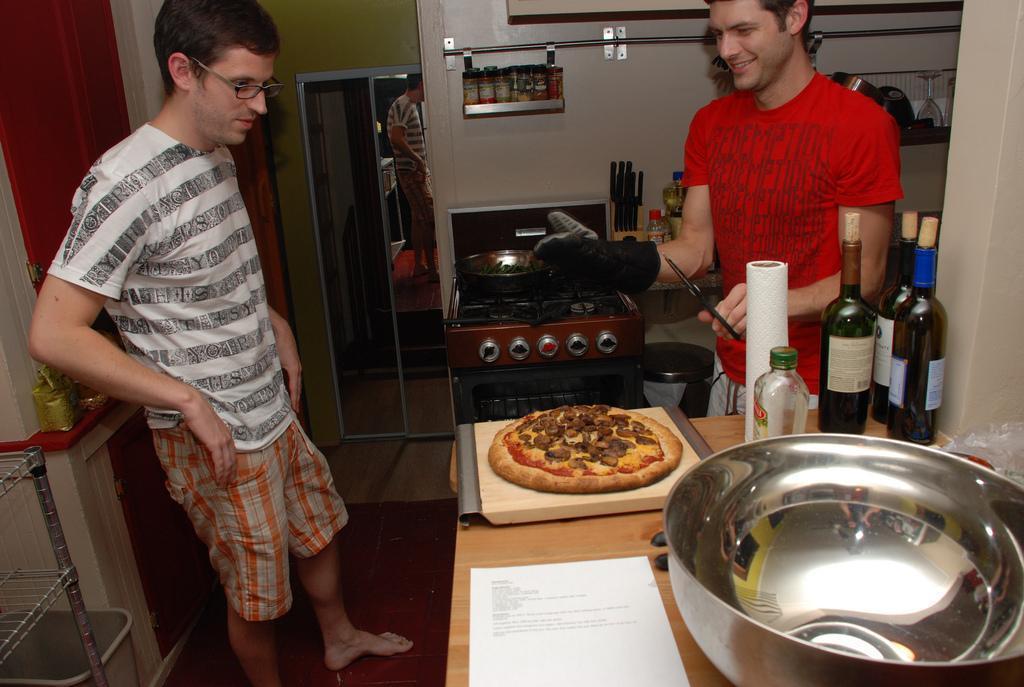How many men are there?
Give a very brief answer. 2. How many mixing bowls are there?
Give a very brief answer. 1. How many wine bottles have corks?
Give a very brief answer. 3. How many people are present?
Give a very brief answer. 2. How many oven mitts are there?
Give a very brief answer. 1. How many striped shirts are there?
Give a very brief answer. 1. How many wine bottles are there?
Give a very brief answer. 3. 